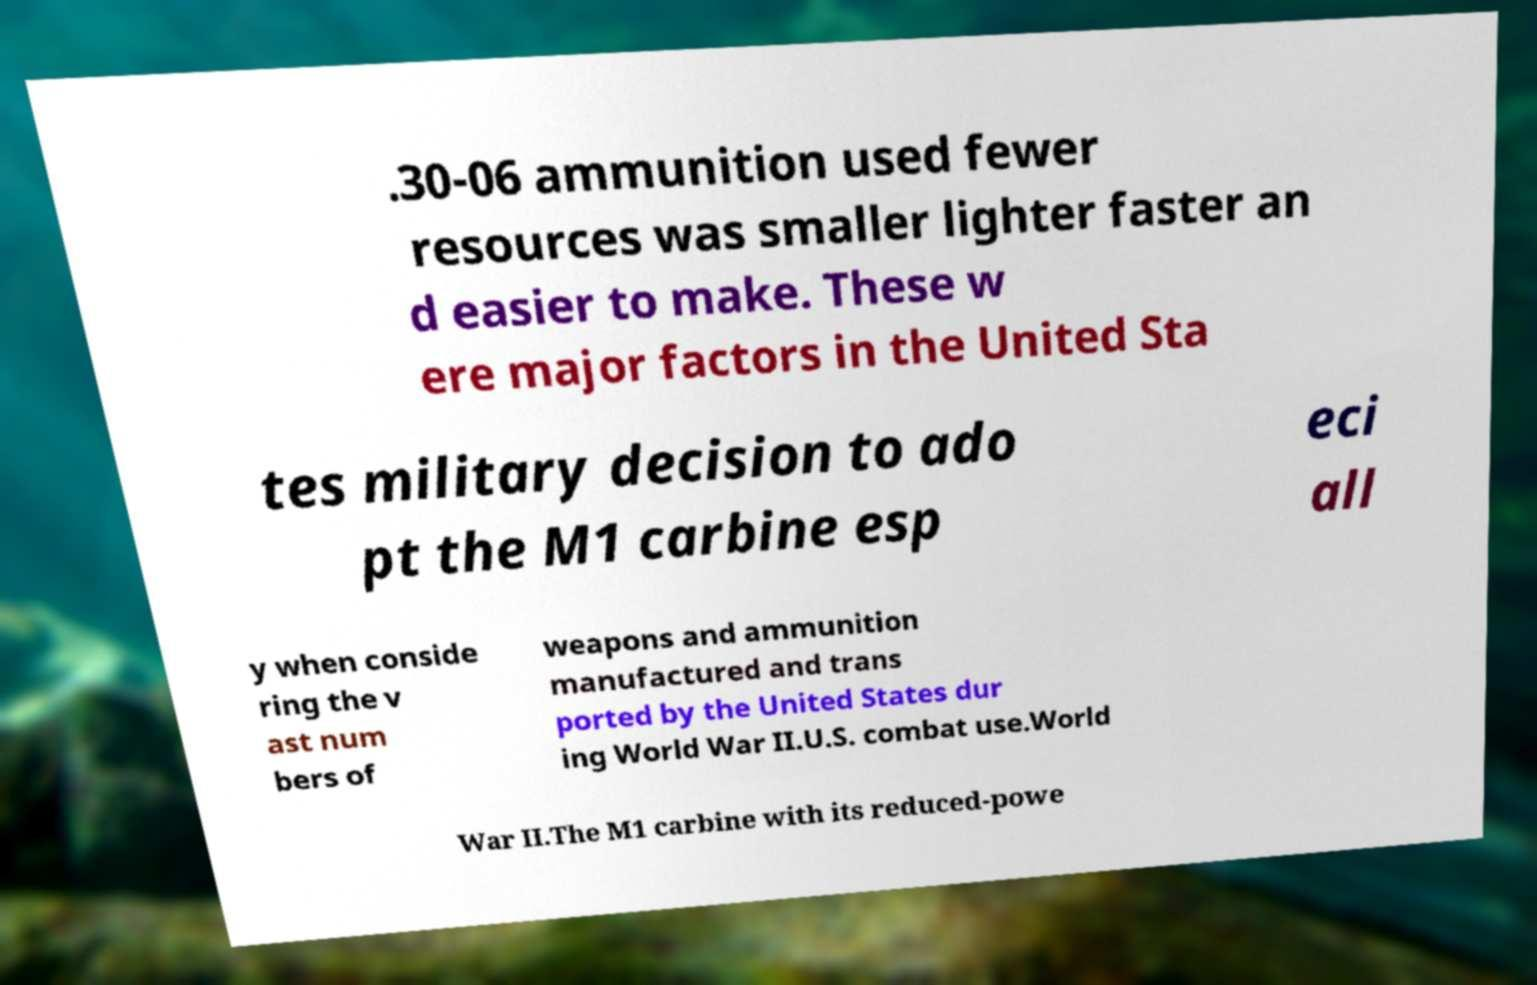For documentation purposes, I need the text within this image transcribed. Could you provide that? .30-06 ammunition used fewer resources was smaller lighter faster an d easier to make. These w ere major factors in the United Sta tes military decision to ado pt the M1 carbine esp eci all y when conside ring the v ast num bers of weapons and ammunition manufactured and trans ported by the United States dur ing World War II.U.S. combat use.World War II.The M1 carbine with its reduced-powe 